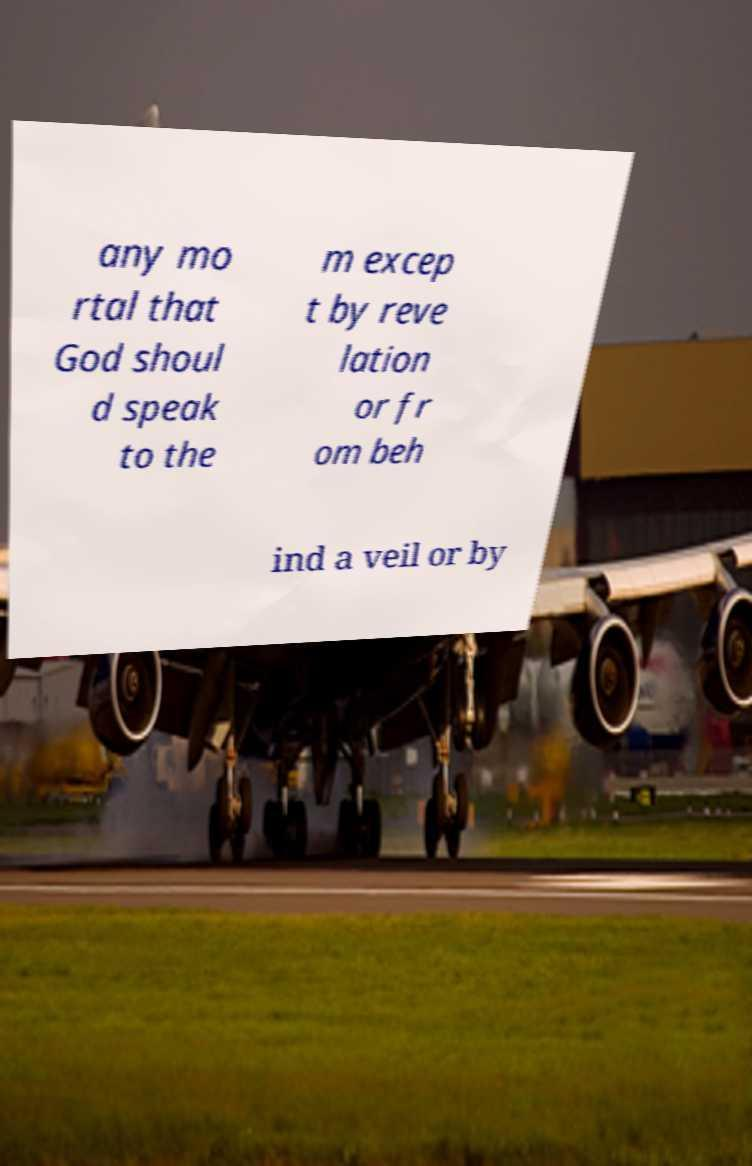Can you read and provide the text displayed in the image?This photo seems to have some interesting text. Can you extract and type it out for me? any mo rtal that God shoul d speak to the m excep t by reve lation or fr om beh ind a veil or by 